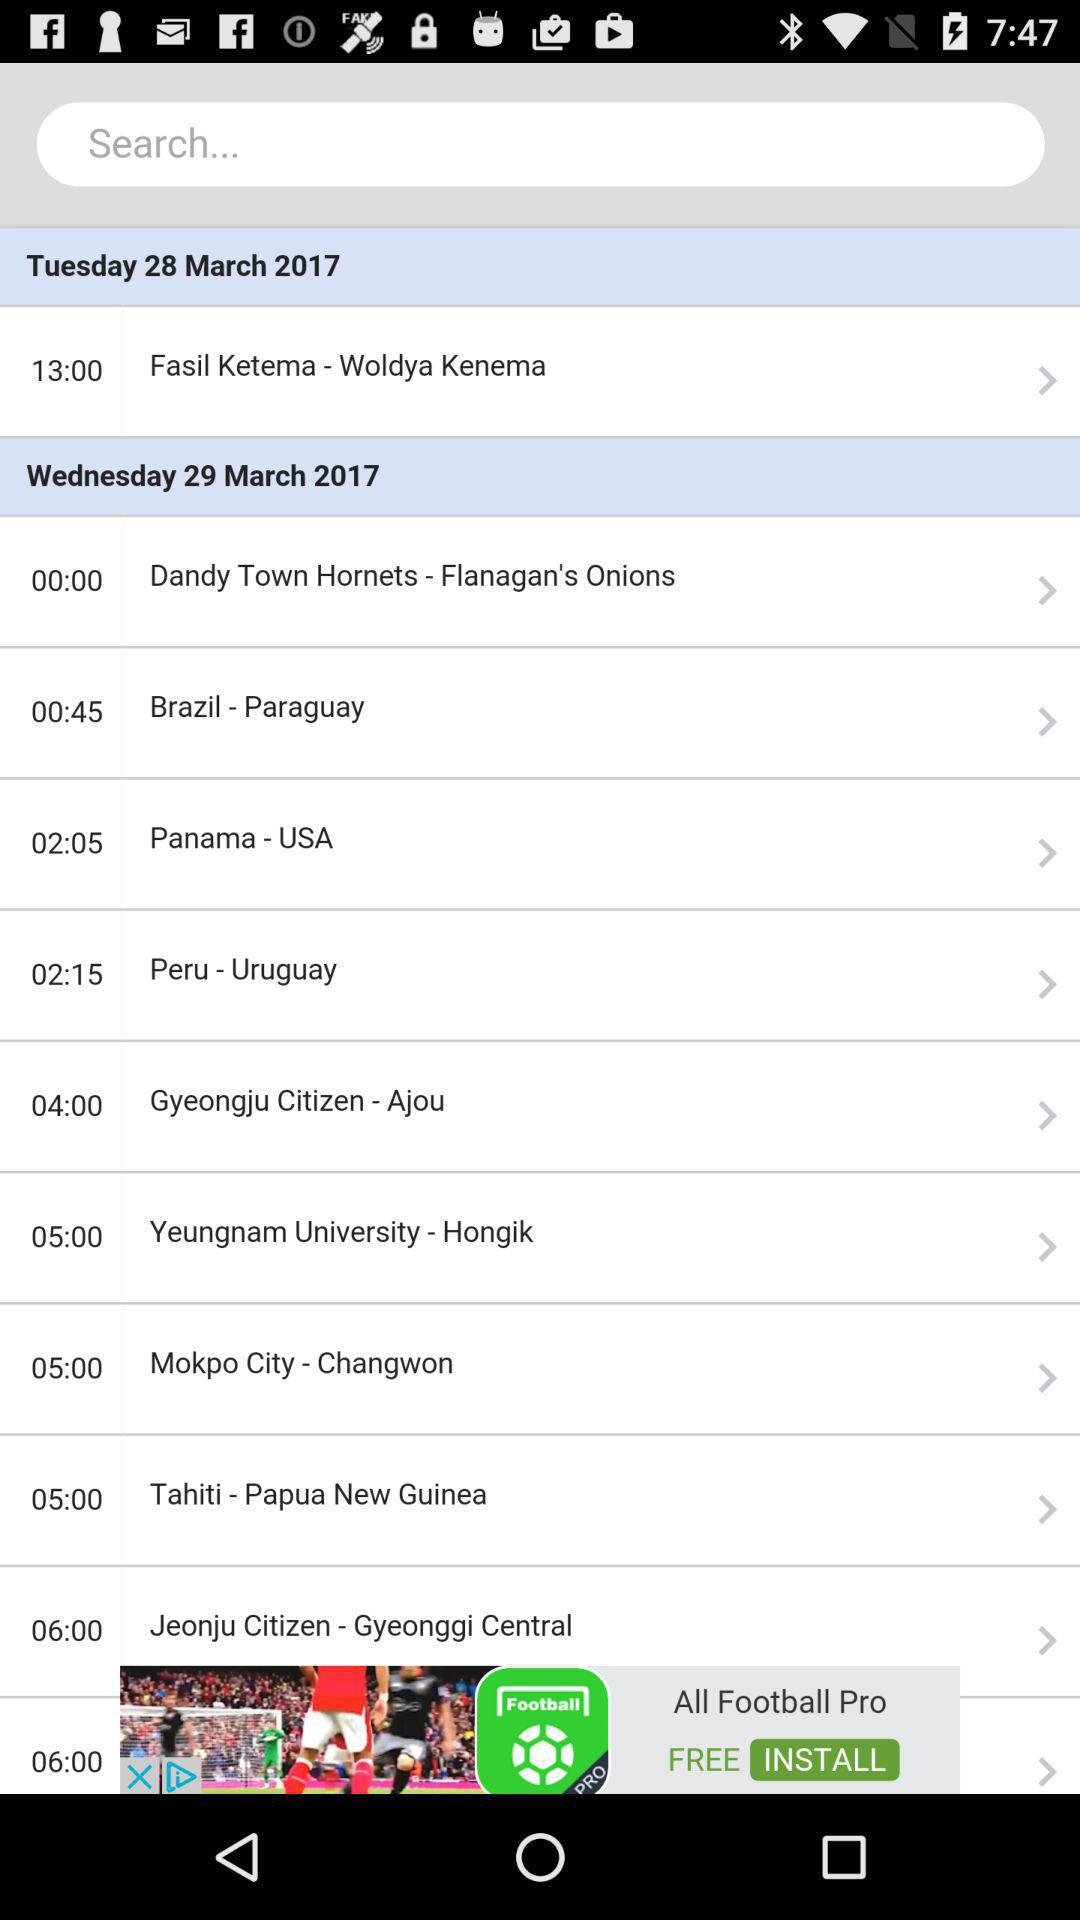What is the day on the 28th of March 2017? The day is Tuesday. 